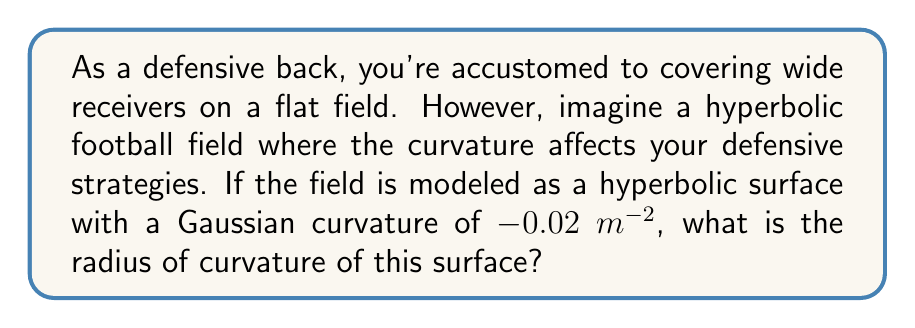What is the answer to this math problem? Let's approach this step-by-step:

1) In hyperbolic geometry, the Gaussian curvature $K$ is constant and negative. We're given that $K = -0.02$ $m^{-2}$.

2) The relationship between Gaussian curvature $K$ and the radius of curvature $R$ in hyperbolic geometry is:

   $$K = -\frac{1}{R^2}$$

3) We need to solve this equation for $R$:

   $$-0.02 = -\frac{1}{R^2}$$

4) Multiply both sides by $-1$:

   $$0.02 = \frac{1}{R^2}$$

5) Take the reciprocal of both sides:

   $$\frac{1}{0.02} = R^2$$

6) Simplify:

   $$50 = R^2$$

7) Take the square root of both sides:

   $$R = \sqrt{50} = 5\sqrt{2}$$

Therefore, the radius of curvature is $5\sqrt{2}$ meters.

This curved field would require adjustments in your defensive strategies. The hyperbolic nature of the field means that parallel lines diverge, which could affect how you perceive and react to the routes of receivers.
Answer: $5\sqrt{2}$ m 